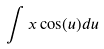Convert formula to latex. <formula><loc_0><loc_0><loc_500><loc_500>\int x \cos ( u ) d u</formula> 